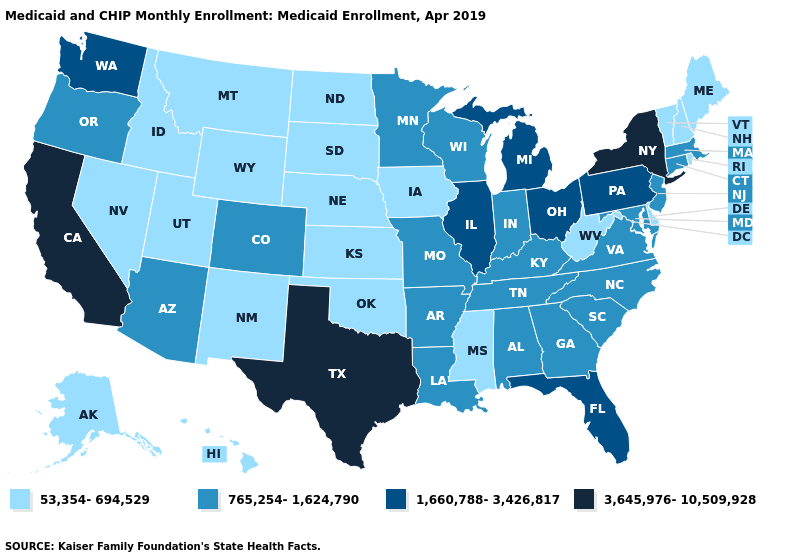Which states have the highest value in the USA?
Be succinct. California, New York, Texas. Name the states that have a value in the range 3,645,976-10,509,928?
Short answer required. California, New York, Texas. Name the states that have a value in the range 765,254-1,624,790?
Write a very short answer. Alabama, Arizona, Arkansas, Colorado, Connecticut, Georgia, Indiana, Kentucky, Louisiana, Maryland, Massachusetts, Minnesota, Missouri, New Jersey, North Carolina, Oregon, South Carolina, Tennessee, Virginia, Wisconsin. What is the value of Wisconsin?
Quick response, please. 765,254-1,624,790. What is the value of New Mexico?
Be succinct. 53,354-694,529. What is the value of New Hampshire?
Answer briefly. 53,354-694,529. Name the states that have a value in the range 1,660,788-3,426,817?
Answer briefly. Florida, Illinois, Michigan, Ohio, Pennsylvania, Washington. Name the states that have a value in the range 765,254-1,624,790?
Short answer required. Alabama, Arizona, Arkansas, Colorado, Connecticut, Georgia, Indiana, Kentucky, Louisiana, Maryland, Massachusetts, Minnesota, Missouri, New Jersey, North Carolina, Oregon, South Carolina, Tennessee, Virginia, Wisconsin. What is the highest value in the USA?
Quick response, please. 3,645,976-10,509,928. Which states have the lowest value in the USA?
Short answer required. Alaska, Delaware, Hawaii, Idaho, Iowa, Kansas, Maine, Mississippi, Montana, Nebraska, Nevada, New Hampshire, New Mexico, North Dakota, Oklahoma, Rhode Island, South Dakota, Utah, Vermont, West Virginia, Wyoming. What is the value of Mississippi?
Answer briefly. 53,354-694,529. What is the lowest value in the MidWest?
Answer briefly. 53,354-694,529. What is the value of Tennessee?
Short answer required. 765,254-1,624,790. Does Alabama have the lowest value in the South?
Give a very brief answer. No. Among the states that border West Virginia , which have the lowest value?
Give a very brief answer. Kentucky, Maryland, Virginia. 